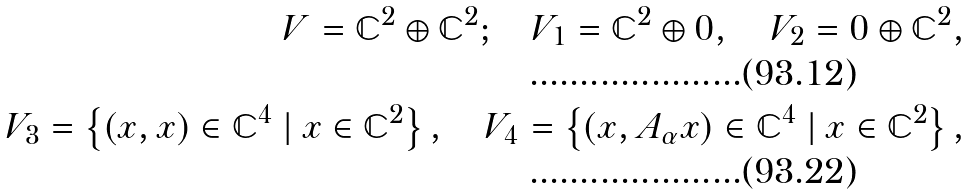Convert formula to latex. <formula><loc_0><loc_0><loc_500><loc_500>V = \mathbb { C } ^ { 2 } \oplus \mathbb { C } ^ { 2 } ; \quad V _ { 1 } = \mathbb { C } ^ { 2 } \oplus 0 , \quad V _ { 2 } = 0 \oplus \mathbb { C } ^ { 2 } , \\ V _ { 3 } = \left \{ ( x , x ) \in \mathbb { C } ^ { 4 } \ | \ x \in \mathbb { C } ^ { 2 } \right \} , \quad V _ { 4 } = \left \{ ( x , A _ { \alpha } x ) \in \mathbb { C } ^ { 4 } \ | \ x \in \mathbb { C } ^ { 2 } \right \} ,</formula> 